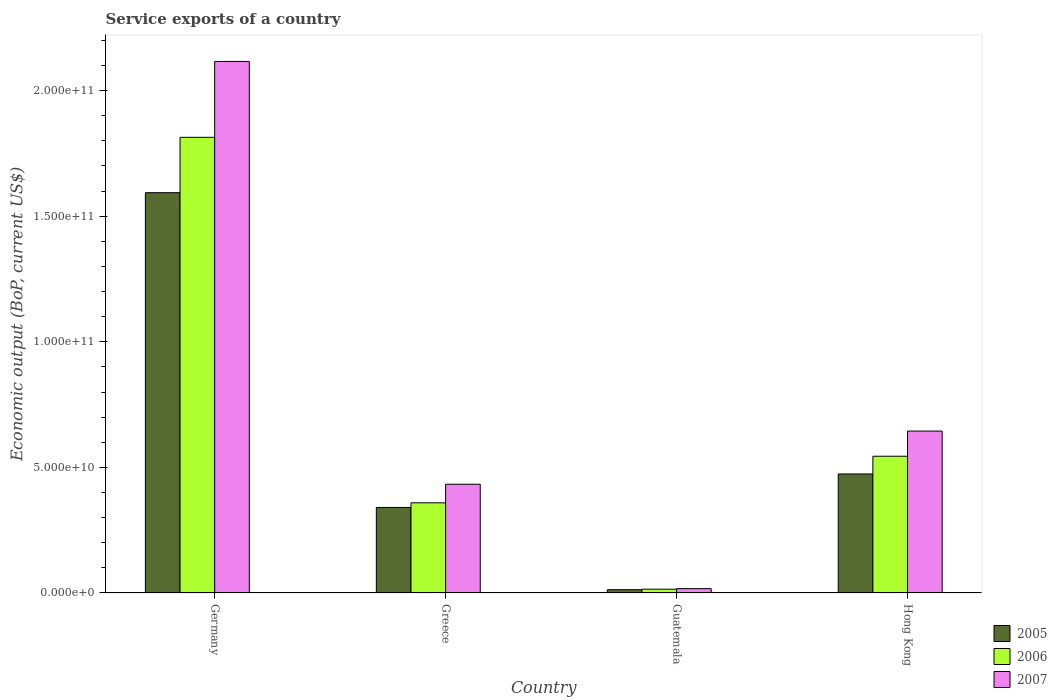How many groups of bars are there?
Provide a succinct answer. 4. What is the label of the 2nd group of bars from the left?
Keep it short and to the point. Greece. What is the service exports in 2005 in Germany?
Ensure brevity in your answer.  1.59e+11. Across all countries, what is the maximum service exports in 2005?
Make the answer very short. 1.59e+11. Across all countries, what is the minimum service exports in 2007?
Ensure brevity in your answer.  1.73e+09. In which country was the service exports in 2007 minimum?
Provide a succinct answer. Guatemala. What is the total service exports in 2007 in the graph?
Make the answer very short. 3.21e+11. What is the difference between the service exports in 2007 in Greece and that in Guatemala?
Keep it short and to the point. 4.16e+1. What is the difference between the service exports in 2005 in Guatemala and the service exports in 2007 in Hong Kong?
Make the answer very short. -6.31e+1. What is the average service exports in 2005 per country?
Keep it short and to the point. 6.05e+1. What is the difference between the service exports of/in 2005 and service exports of/in 2007 in Guatemala?
Keep it short and to the point. -4.23e+08. What is the ratio of the service exports in 2007 in Germany to that in Hong Kong?
Make the answer very short. 3.28. What is the difference between the highest and the second highest service exports in 2005?
Offer a terse response. 1.12e+11. What is the difference between the highest and the lowest service exports in 2007?
Ensure brevity in your answer.  2.10e+11. Is the sum of the service exports in 2007 in Greece and Hong Kong greater than the maximum service exports in 2006 across all countries?
Offer a very short reply. No. What does the 3rd bar from the left in Hong Kong represents?
Offer a terse response. 2007. What does the 3rd bar from the right in Hong Kong represents?
Ensure brevity in your answer.  2005. Is it the case that in every country, the sum of the service exports in 2006 and service exports in 2005 is greater than the service exports in 2007?
Offer a very short reply. Yes. How many bars are there?
Provide a succinct answer. 12. What is the difference between two consecutive major ticks on the Y-axis?
Your response must be concise. 5.00e+1. Are the values on the major ticks of Y-axis written in scientific E-notation?
Keep it short and to the point. Yes. Where does the legend appear in the graph?
Make the answer very short. Bottom right. What is the title of the graph?
Your response must be concise. Service exports of a country. What is the label or title of the X-axis?
Your answer should be very brief. Country. What is the label or title of the Y-axis?
Keep it short and to the point. Economic output (BoP, current US$). What is the Economic output (BoP, current US$) of 2005 in Germany?
Offer a terse response. 1.59e+11. What is the Economic output (BoP, current US$) in 2006 in Germany?
Offer a terse response. 1.81e+11. What is the Economic output (BoP, current US$) of 2007 in Germany?
Provide a short and direct response. 2.12e+11. What is the Economic output (BoP, current US$) of 2005 in Greece?
Ensure brevity in your answer.  3.41e+1. What is the Economic output (BoP, current US$) of 2006 in Greece?
Ensure brevity in your answer.  3.59e+1. What is the Economic output (BoP, current US$) of 2007 in Greece?
Your answer should be very brief. 4.33e+1. What is the Economic output (BoP, current US$) in 2005 in Guatemala?
Your response must be concise. 1.31e+09. What is the Economic output (BoP, current US$) in 2006 in Guatemala?
Provide a short and direct response. 1.52e+09. What is the Economic output (BoP, current US$) of 2007 in Guatemala?
Offer a terse response. 1.73e+09. What is the Economic output (BoP, current US$) in 2005 in Hong Kong?
Keep it short and to the point. 4.74e+1. What is the Economic output (BoP, current US$) of 2006 in Hong Kong?
Your response must be concise. 5.44e+1. What is the Economic output (BoP, current US$) in 2007 in Hong Kong?
Keep it short and to the point. 6.45e+1. Across all countries, what is the maximum Economic output (BoP, current US$) in 2005?
Give a very brief answer. 1.59e+11. Across all countries, what is the maximum Economic output (BoP, current US$) of 2006?
Keep it short and to the point. 1.81e+11. Across all countries, what is the maximum Economic output (BoP, current US$) of 2007?
Provide a succinct answer. 2.12e+11. Across all countries, what is the minimum Economic output (BoP, current US$) of 2005?
Provide a short and direct response. 1.31e+09. Across all countries, what is the minimum Economic output (BoP, current US$) of 2006?
Give a very brief answer. 1.52e+09. Across all countries, what is the minimum Economic output (BoP, current US$) of 2007?
Ensure brevity in your answer.  1.73e+09. What is the total Economic output (BoP, current US$) of 2005 in the graph?
Offer a very short reply. 2.42e+11. What is the total Economic output (BoP, current US$) of 2006 in the graph?
Keep it short and to the point. 2.73e+11. What is the total Economic output (BoP, current US$) in 2007 in the graph?
Your answer should be very brief. 3.21e+11. What is the difference between the Economic output (BoP, current US$) in 2005 in Germany and that in Greece?
Your response must be concise. 1.25e+11. What is the difference between the Economic output (BoP, current US$) in 2006 in Germany and that in Greece?
Your answer should be very brief. 1.45e+11. What is the difference between the Economic output (BoP, current US$) of 2007 in Germany and that in Greece?
Your response must be concise. 1.68e+11. What is the difference between the Economic output (BoP, current US$) in 2005 in Germany and that in Guatemala?
Make the answer very short. 1.58e+11. What is the difference between the Economic output (BoP, current US$) in 2006 in Germany and that in Guatemala?
Keep it short and to the point. 1.80e+11. What is the difference between the Economic output (BoP, current US$) in 2007 in Germany and that in Guatemala?
Provide a short and direct response. 2.10e+11. What is the difference between the Economic output (BoP, current US$) of 2005 in Germany and that in Hong Kong?
Your response must be concise. 1.12e+11. What is the difference between the Economic output (BoP, current US$) of 2006 in Germany and that in Hong Kong?
Provide a succinct answer. 1.27e+11. What is the difference between the Economic output (BoP, current US$) of 2007 in Germany and that in Hong Kong?
Keep it short and to the point. 1.47e+11. What is the difference between the Economic output (BoP, current US$) of 2005 in Greece and that in Guatemala?
Provide a short and direct response. 3.27e+1. What is the difference between the Economic output (BoP, current US$) in 2006 in Greece and that in Guatemala?
Your answer should be very brief. 3.44e+1. What is the difference between the Economic output (BoP, current US$) in 2007 in Greece and that in Guatemala?
Give a very brief answer. 4.16e+1. What is the difference between the Economic output (BoP, current US$) of 2005 in Greece and that in Hong Kong?
Offer a very short reply. -1.33e+1. What is the difference between the Economic output (BoP, current US$) in 2006 in Greece and that in Hong Kong?
Provide a short and direct response. -1.85e+1. What is the difference between the Economic output (BoP, current US$) in 2007 in Greece and that in Hong Kong?
Offer a terse response. -2.12e+1. What is the difference between the Economic output (BoP, current US$) of 2005 in Guatemala and that in Hong Kong?
Keep it short and to the point. -4.61e+1. What is the difference between the Economic output (BoP, current US$) of 2006 in Guatemala and that in Hong Kong?
Ensure brevity in your answer.  -5.29e+1. What is the difference between the Economic output (BoP, current US$) of 2007 in Guatemala and that in Hong Kong?
Offer a terse response. -6.27e+1. What is the difference between the Economic output (BoP, current US$) of 2005 in Germany and the Economic output (BoP, current US$) of 2006 in Greece?
Provide a short and direct response. 1.23e+11. What is the difference between the Economic output (BoP, current US$) of 2005 in Germany and the Economic output (BoP, current US$) of 2007 in Greece?
Give a very brief answer. 1.16e+11. What is the difference between the Economic output (BoP, current US$) in 2006 in Germany and the Economic output (BoP, current US$) in 2007 in Greece?
Offer a very short reply. 1.38e+11. What is the difference between the Economic output (BoP, current US$) in 2005 in Germany and the Economic output (BoP, current US$) in 2006 in Guatemala?
Keep it short and to the point. 1.58e+11. What is the difference between the Economic output (BoP, current US$) of 2005 in Germany and the Economic output (BoP, current US$) of 2007 in Guatemala?
Offer a very short reply. 1.58e+11. What is the difference between the Economic output (BoP, current US$) in 2006 in Germany and the Economic output (BoP, current US$) in 2007 in Guatemala?
Your answer should be compact. 1.80e+11. What is the difference between the Economic output (BoP, current US$) in 2005 in Germany and the Economic output (BoP, current US$) in 2006 in Hong Kong?
Your answer should be compact. 1.05e+11. What is the difference between the Economic output (BoP, current US$) in 2005 in Germany and the Economic output (BoP, current US$) in 2007 in Hong Kong?
Make the answer very short. 9.49e+1. What is the difference between the Economic output (BoP, current US$) in 2006 in Germany and the Economic output (BoP, current US$) in 2007 in Hong Kong?
Provide a succinct answer. 1.17e+11. What is the difference between the Economic output (BoP, current US$) of 2005 in Greece and the Economic output (BoP, current US$) of 2006 in Guatemala?
Your answer should be very brief. 3.25e+1. What is the difference between the Economic output (BoP, current US$) in 2005 in Greece and the Economic output (BoP, current US$) in 2007 in Guatemala?
Give a very brief answer. 3.23e+1. What is the difference between the Economic output (BoP, current US$) in 2006 in Greece and the Economic output (BoP, current US$) in 2007 in Guatemala?
Offer a terse response. 3.42e+1. What is the difference between the Economic output (BoP, current US$) in 2005 in Greece and the Economic output (BoP, current US$) in 2006 in Hong Kong?
Provide a succinct answer. -2.04e+1. What is the difference between the Economic output (BoP, current US$) in 2005 in Greece and the Economic output (BoP, current US$) in 2007 in Hong Kong?
Your answer should be very brief. -3.04e+1. What is the difference between the Economic output (BoP, current US$) of 2006 in Greece and the Economic output (BoP, current US$) of 2007 in Hong Kong?
Make the answer very short. -2.86e+1. What is the difference between the Economic output (BoP, current US$) in 2005 in Guatemala and the Economic output (BoP, current US$) in 2006 in Hong Kong?
Make the answer very short. -5.31e+1. What is the difference between the Economic output (BoP, current US$) in 2005 in Guatemala and the Economic output (BoP, current US$) in 2007 in Hong Kong?
Provide a short and direct response. -6.31e+1. What is the difference between the Economic output (BoP, current US$) in 2006 in Guatemala and the Economic output (BoP, current US$) in 2007 in Hong Kong?
Ensure brevity in your answer.  -6.29e+1. What is the average Economic output (BoP, current US$) of 2005 per country?
Offer a very short reply. 6.05e+1. What is the average Economic output (BoP, current US$) of 2006 per country?
Your response must be concise. 6.83e+1. What is the average Economic output (BoP, current US$) in 2007 per country?
Your answer should be compact. 8.03e+1. What is the difference between the Economic output (BoP, current US$) in 2005 and Economic output (BoP, current US$) in 2006 in Germany?
Keep it short and to the point. -2.20e+1. What is the difference between the Economic output (BoP, current US$) in 2005 and Economic output (BoP, current US$) in 2007 in Germany?
Your answer should be very brief. -5.22e+1. What is the difference between the Economic output (BoP, current US$) of 2006 and Economic output (BoP, current US$) of 2007 in Germany?
Offer a terse response. -3.02e+1. What is the difference between the Economic output (BoP, current US$) of 2005 and Economic output (BoP, current US$) of 2006 in Greece?
Your answer should be very brief. -1.85e+09. What is the difference between the Economic output (BoP, current US$) of 2005 and Economic output (BoP, current US$) of 2007 in Greece?
Your response must be concise. -9.24e+09. What is the difference between the Economic output (BoP, current US$) in 2006 and Economic output (BoP, current US$) in 2007 in Greece?
Keep it short and to the point. -7.39e+09. What is the difference between the Economic output (BoP, current US$) of 2005 and Economic output (BoP, current US$) of 2006 in Guatemala?
Provide a short and direct response. -2.11e+08. What is the difference between the Economic output (BoP, current US$) in 2005 and Economic output (BoP, current US$) in 2007 in Guatemala?
Give a very brief answer. -4.23e+08. What is the difference between the Economic output (BoP, current US$) of 2006 and Economic output (BoP, current US$) of 2007 in Guatemala?
Provide a succinct answer. -2.12e+08. What is the difference between the Economic output (BoP, current US$) in 2005 and Economic output (BoP, current US$) in 2006 in Hong Kong?
Provide a succinct answer. -7.06e+09. What is the difference between the Economic output (BoP, current US$) of 2005 and Economic output (BoP, current US$) of 2007 in Hong Kong?
Keep it short and to the point. -1.71e+1. What is the difference between the Economic output (BoP, current US$) of 2006 and Economic output (BoP, current US$) of 2007 in Hong Kong?
Give a very brief answer. -1.00e+1. What is the ratio of the Economic output (BoP, current US$) in 2005 in Germany to that in Greece?
Offer a very short reply. 4.68. What is the ratio of the Economic output (BoP, current US$) of 2006 in Germany to that in Greece?
Ensure brevity in your answer.  5.05. What is the ratio of the Economic output (BoP, current US$) of 2007 in Germany to that in Greece?
Ensure brevity in your answer.  4.89. What is the ratio of the Economic output (BoP, current US$) in 2005 in Germany to that in Guatemala?
Make the answer very short. 121.84. What is the ratio of the Economic output (BoP, current US$) in 2006 in Germany to that in Guatemala?
Make the answer very short. 119.42. What is the ratio of the Economic output (BoP, current US$) of 2007 in Germany to that in Guatemala?
Offer a terse response. 122.22. What is the ratio of the Economic output (BoP, current US$) in 2005 in Germany to that in Hong Kong?
Give a very brief answer. 3.36. What is the ratio of the Economic output (BoP, current US$) in 2006 in Germany to that in Hong Kong?
Make the answer very short. 3.33. What is the ratio of the Economic output (BoP, current US$) of 2007 in Germany to that in Hong Kong?
Offer a terse response. 3.28. What is the ratio of the Economic output (BoP, current US$) of 2005 in Greece to that in Guatemala?
Your answer should be compact. 26.04. What is the ratio of the Economic output (BoP, current US$) of 2006 in Greece to that in Guatemala?
Give a very brief answer. 23.64. What is the ratio of the Economic output (BoP, current US$) of 2007 in Greece to that in Guatemala?
Give a very brief answer. 25. What is the ratio of the Economic output (BoP, current US$) in 2005 in Greece to that in Hong Kong?
Provide a succinct answer. 0.72. What is the ratio of the Economic output (BoP, current US$) in 2006 in Greece to that in Hong Kong?
Make the answer very short. 0.66. What is the ratio of the Economic output (BoP, current US$) of 2007 in Greece to that in Hong Kong?
Your response must be concise. 0.67. What is the ratio of the Economic output (BoP, current US$) in 2005 in Guatemala to that in Hong Kong?
Offer a very short reply. 0.03. What is the ratio of the Economic output (BoP, current US$) of 2006 in Guatemala to that in Hong Kong?
Offer a terse response. 0.03. What is the ratio of the Economic output (BoP, current US$) of 2007 in Guatemala to that in Hong Kong?
Offer a terse response. 0.03. What is the difference between the highest and the second highest Economic output (BoP, current US$) in 2005?
Give a very brief answer. 1.12e+11. What is the difference between the highest and the second highest Economic output (BoP, current US$) in 2006?
Offer a terse response. 1.27e+11. What is the difference between the highest and the second highest Economic output (BoP, current US$) of 2007?
Keep it short and to the point. 1.47e+11. What is the difference between the highest and the lowest Economic output (BoP, current US$) of 2005?
Make the answer very short. 1.58e+11. What is the difference between the highest and the lowest Economic output (BoP, current US$) in 2006?
Provide a short and direct response. 1.80e+11. What is the difference between the highest and the lowest Economic output (BoP, current US$) of 2007?
Give a very brief answer. 2.10e+11. 